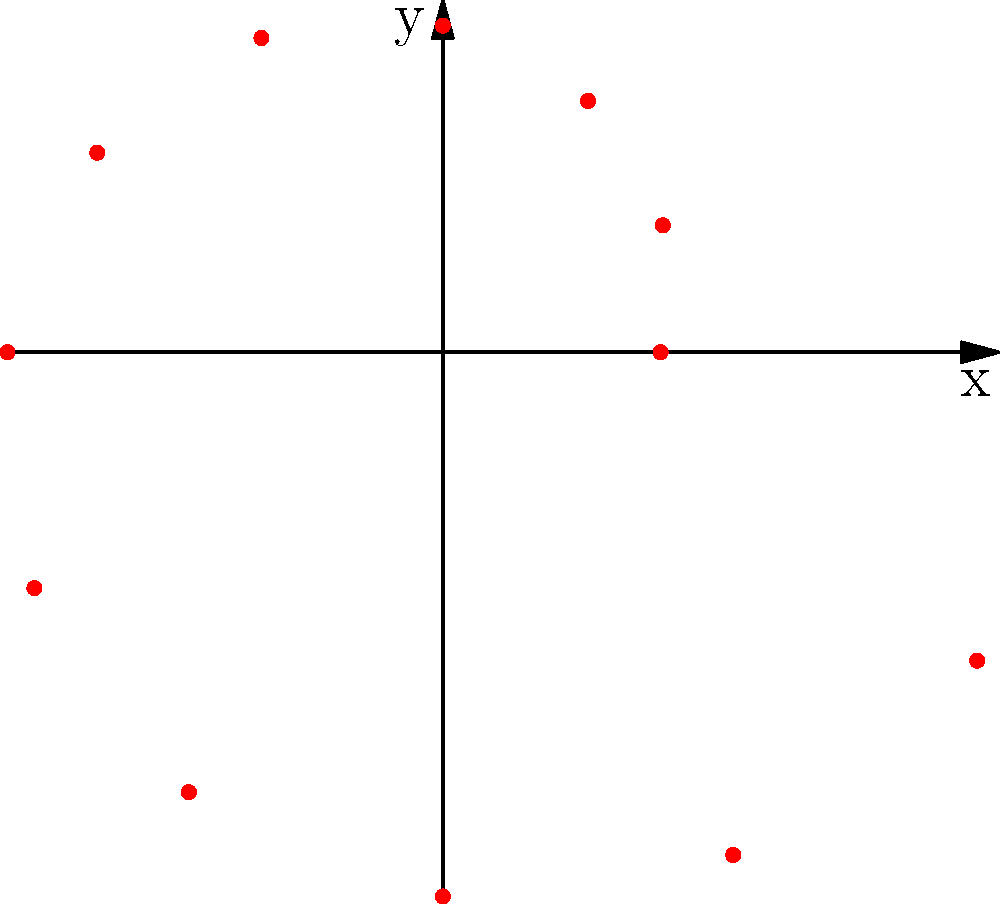Based on the polar scatter plot representing the correlation between racial bias and sentence lengths, what is the maximum sentence length depicted, and at which angle does it occur? To answer this question, we need to analyze the polar scatter plot:

1. In a polar scatter plot, the distance from the origin represents the magnitude (in this case, sentence length), while the angle represents the degree of racial bias.

2. We need to identify the point furthest from the origin, as this represents the maximum sentence length.

3. Examining the plot, we can see that the points form a spiral pattern, with the distance from the origin increasing as we move clockwise.

4. The furthest point from the origin appears to be at approximately the 330-degree position (measured counterclockwise from the positive x-axis).

5. To determine the exact length, we can use the given data:
   angles = {0, 30, 60, 90, 120, 150, 180, 210, 240, 270, 300, 330}
   lengths = {24, 28, 32, 36, 40, 44, 48, 52, 56, 60, 64, 68}

6. The maximum length in the data is 68, which corresponds to the 330-degree angle.

Therefore, the maximum sentence length depicted is 68 (units), occurring at a 330-degree angle.
Answer: 68 units at 330 degrees 